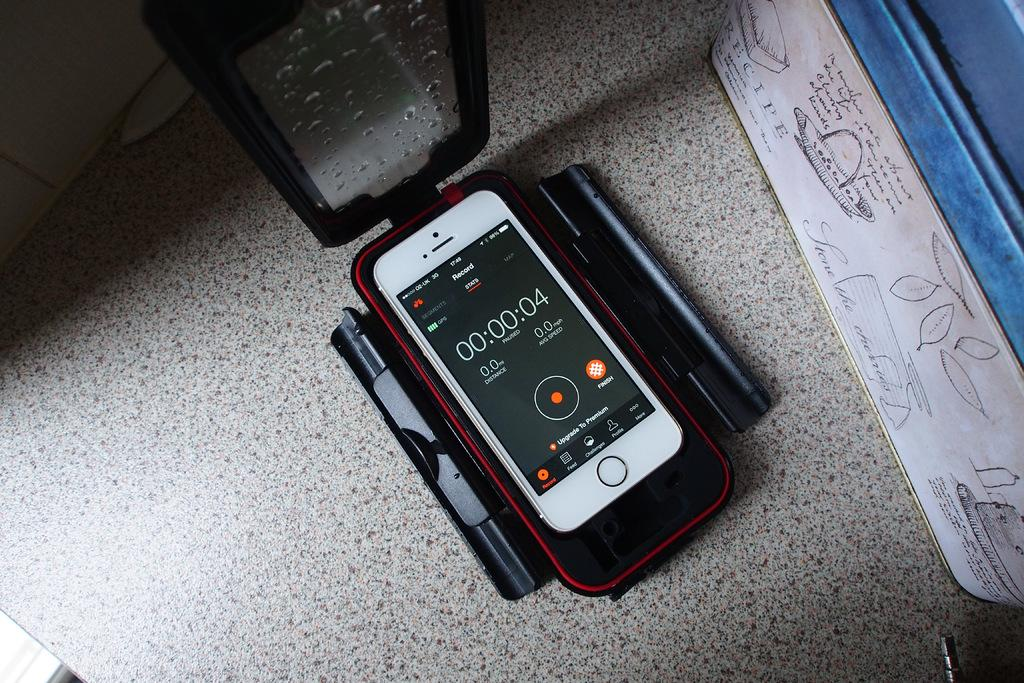<image>
Provide a brief description of the given image. A phone with its protective case's front flipped up has a screen with the word Record near the top. 